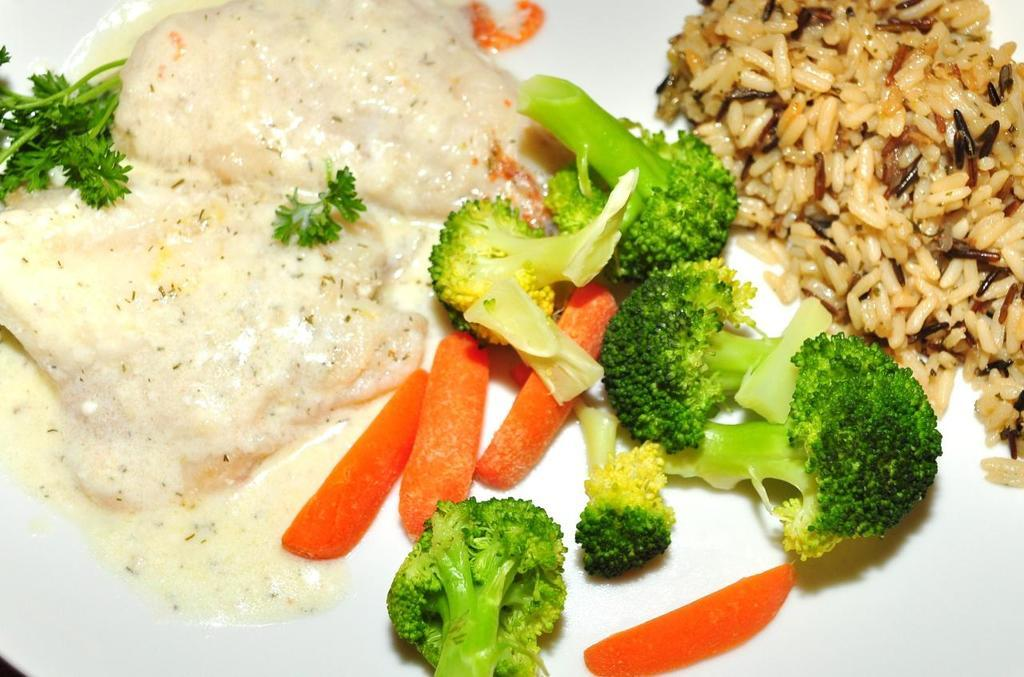What is on the plate in the image? There are broccoli, carrots, rice, leafy vegetables, and other food on the plate. Can you describe the types of vegetables on the plate? The vegetables on the plate include broccoli and carrots, as well as leafy vegetables. What else is on the plate besides vegetables? There is rice and other food on the plate. What month is depicted in the image? There is no month depicted in the image; it is a still image of a plate with food. 